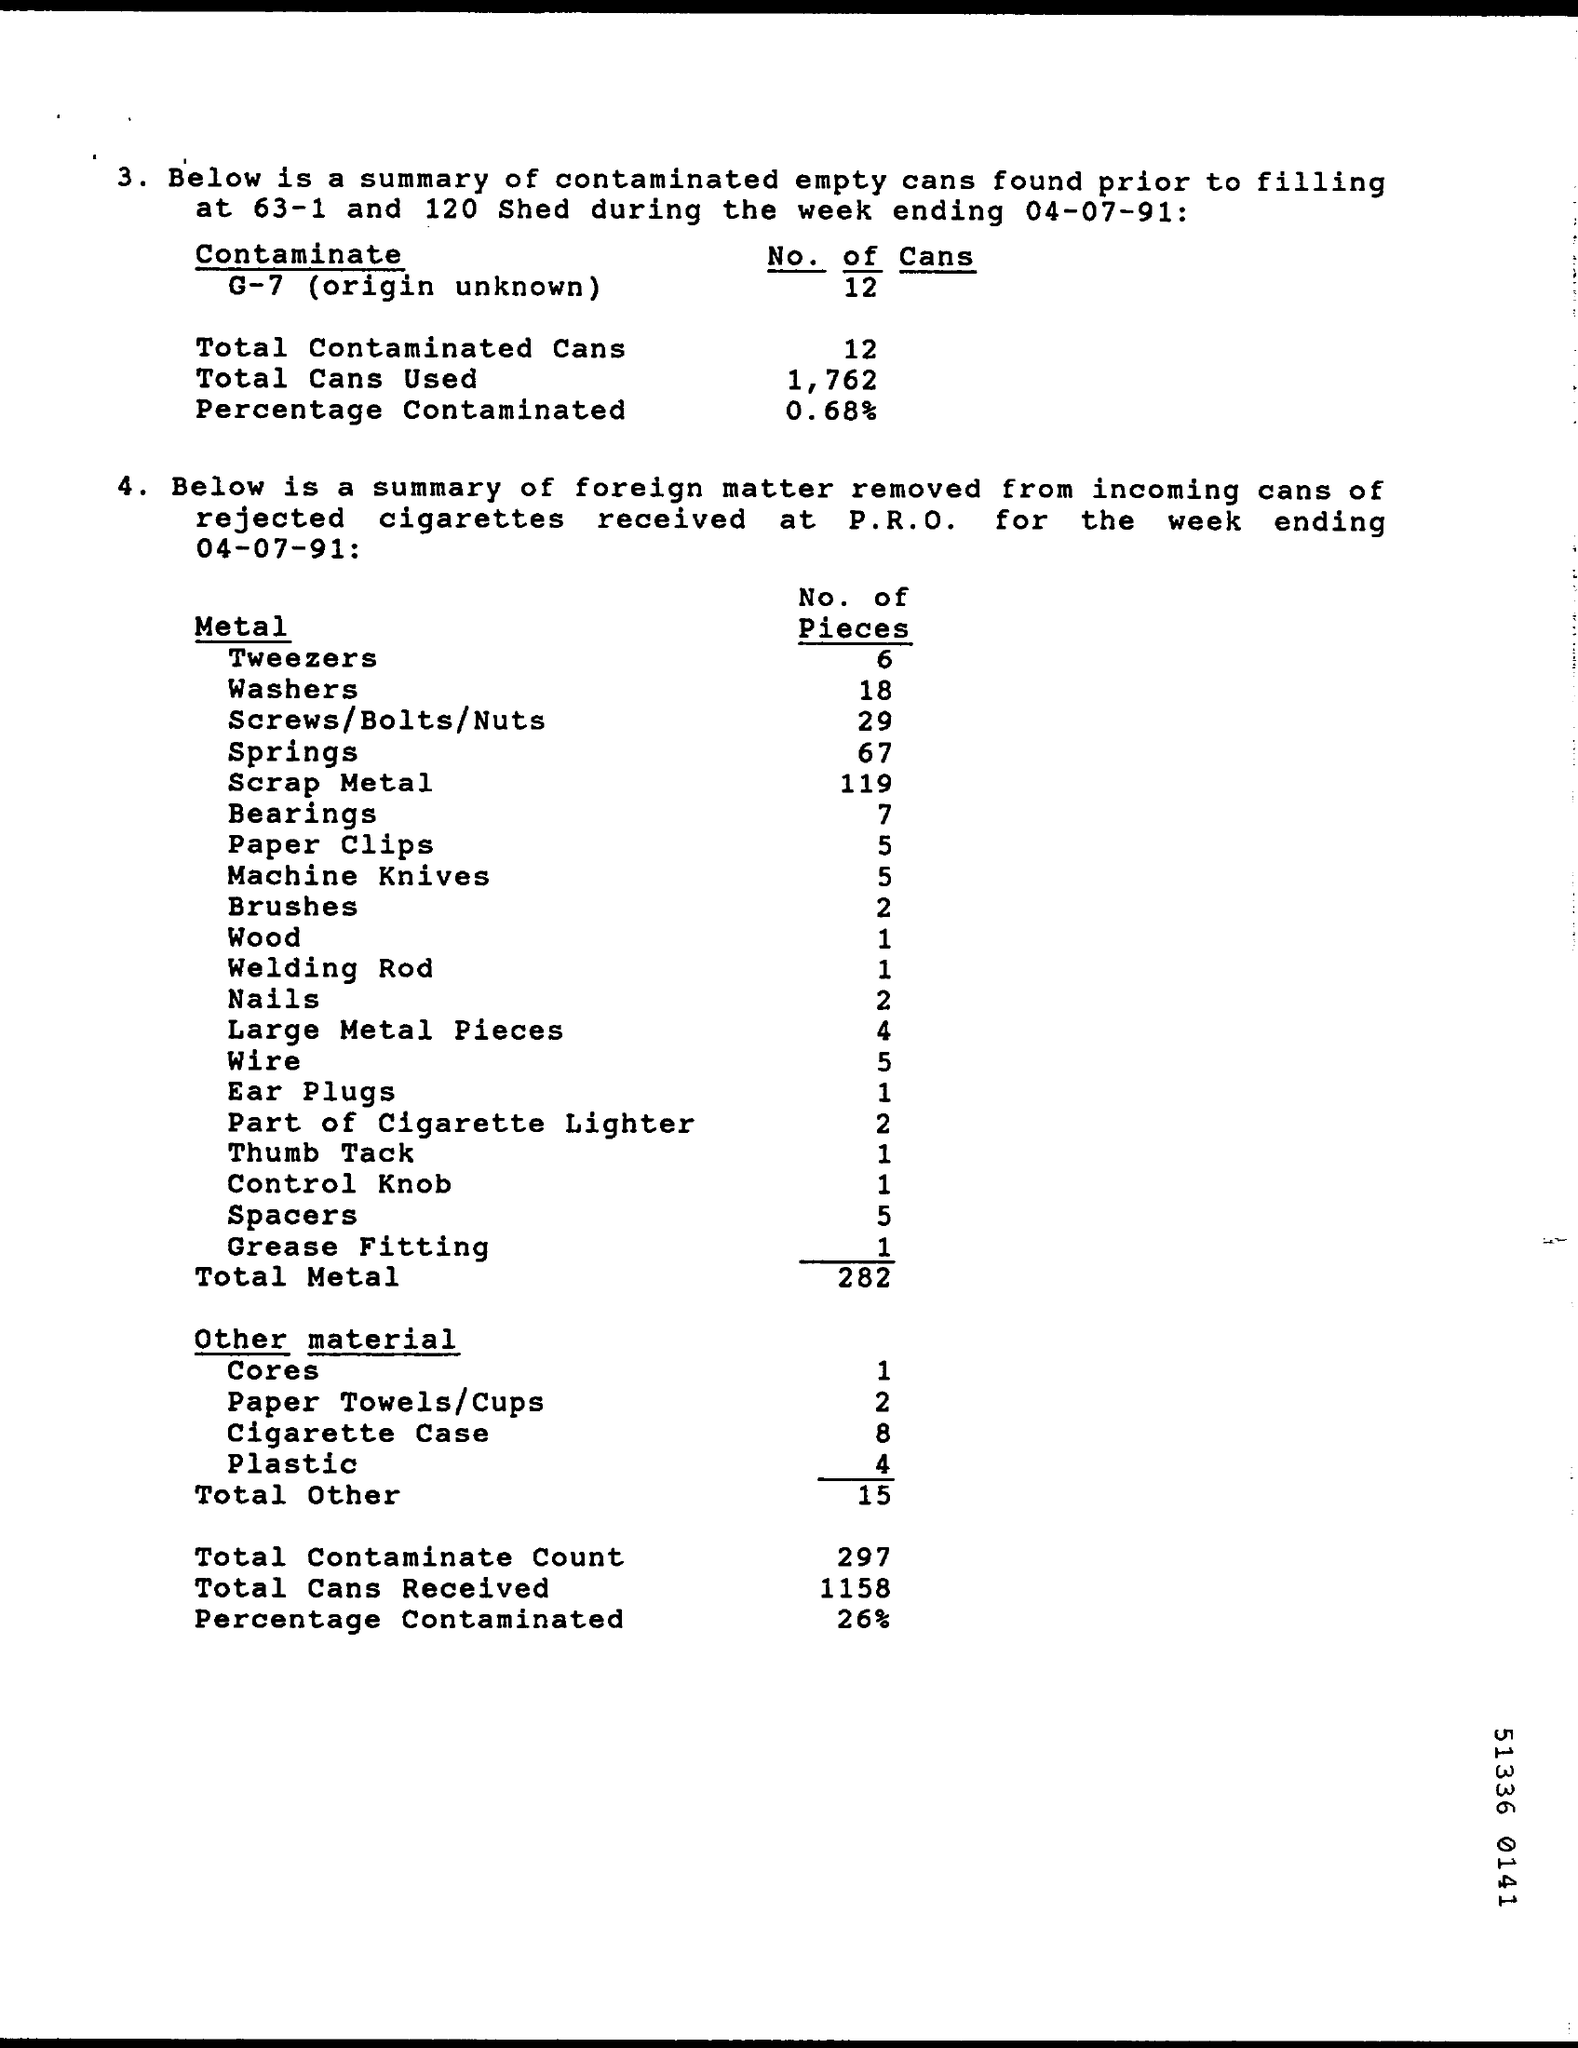Draw attention to some important aspects in this diagram. How many cans are being used? There are 1,762 of them. A total of 1158 cans have been received. The count of total metal is 282. There are 1-4 pieces of wood included in the box. The total amount of other materials is 15.. 